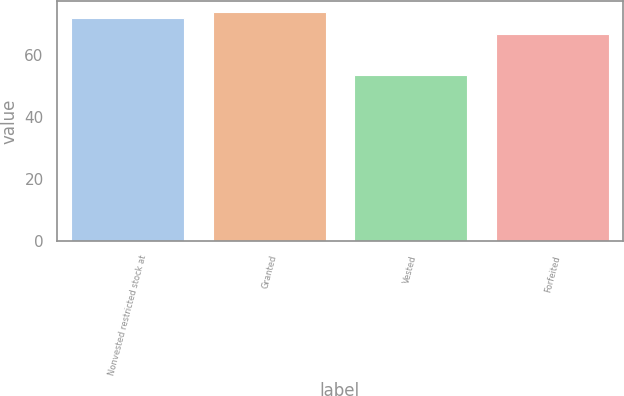Convert chart. <chart><loc_0><loc_0><loc_500><loc_500><bar_chart><fcel>Nonvested restricted stock at<fcel>Granted<fcel>Vested<fcel>Forfeited<nl><fcel>71.84<fcel>73.84<fcel>53.45<fcel>66.83<nl></chart> 